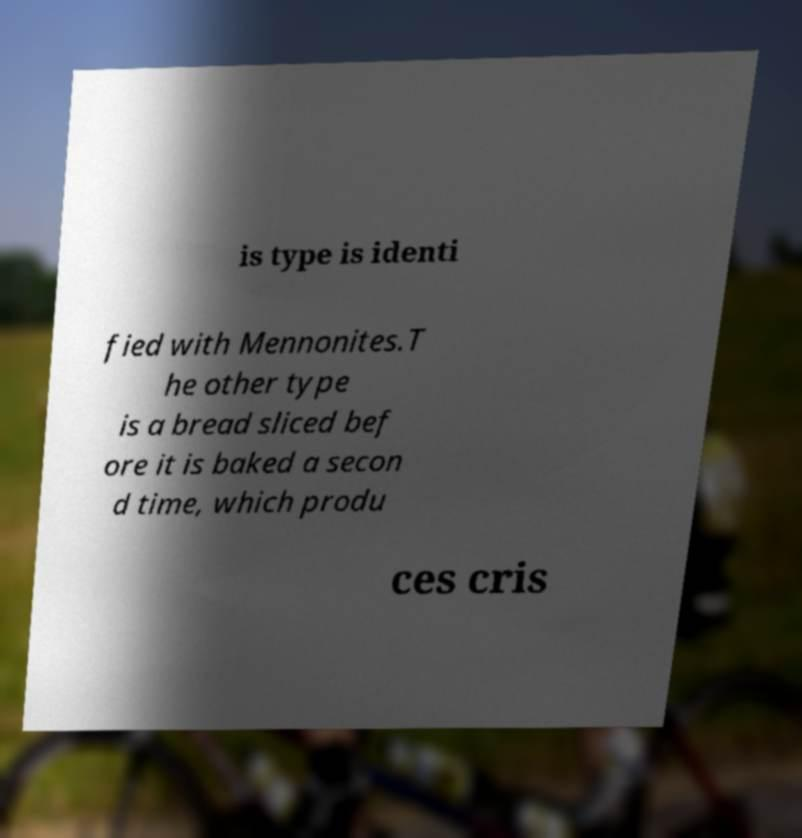I need the written content from this picture converted into text. Can you do that? is type is identi fied with Mennonites.T he other type is a bread sliced bef ore it is baked a secon d time, which produ ces cris 